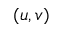<formula> <loc_0><loc_0><loc_500><loc_500>( u , v )</formula> 